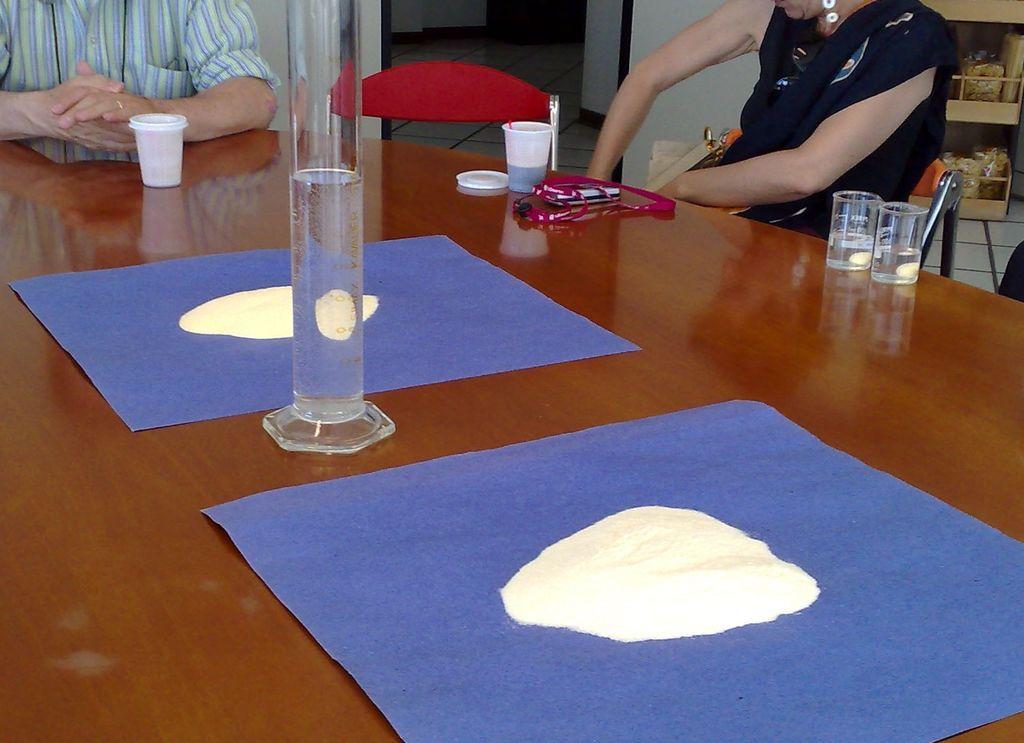Please provide a concise description of this image. There is a glass on table and beside that there are people 